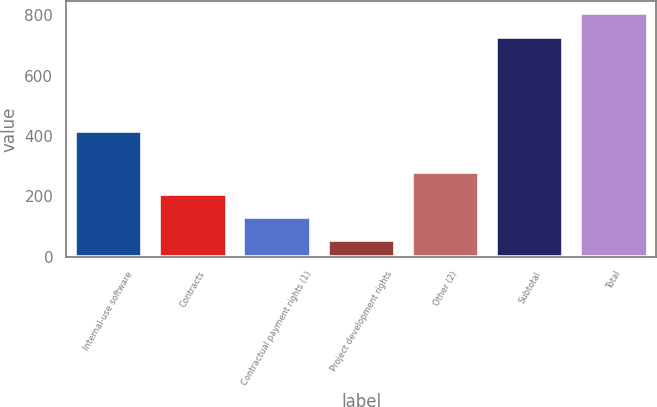Convert chart to OTSL. <chart><loc_0><loc_0><loc_500><loc_500><bar_chart><fcel>Internal-use software<fcel>Contracts<fcel>Contractual payment rights (1)<fcel>Project development rights<fcel>Other (2)<fcel>Subtotal<fcel>Total<nl><fcel>416<fcel>207<fcel>132<fcel>57<fcel>282<fcel>728<fcel>807<nl></chart> 